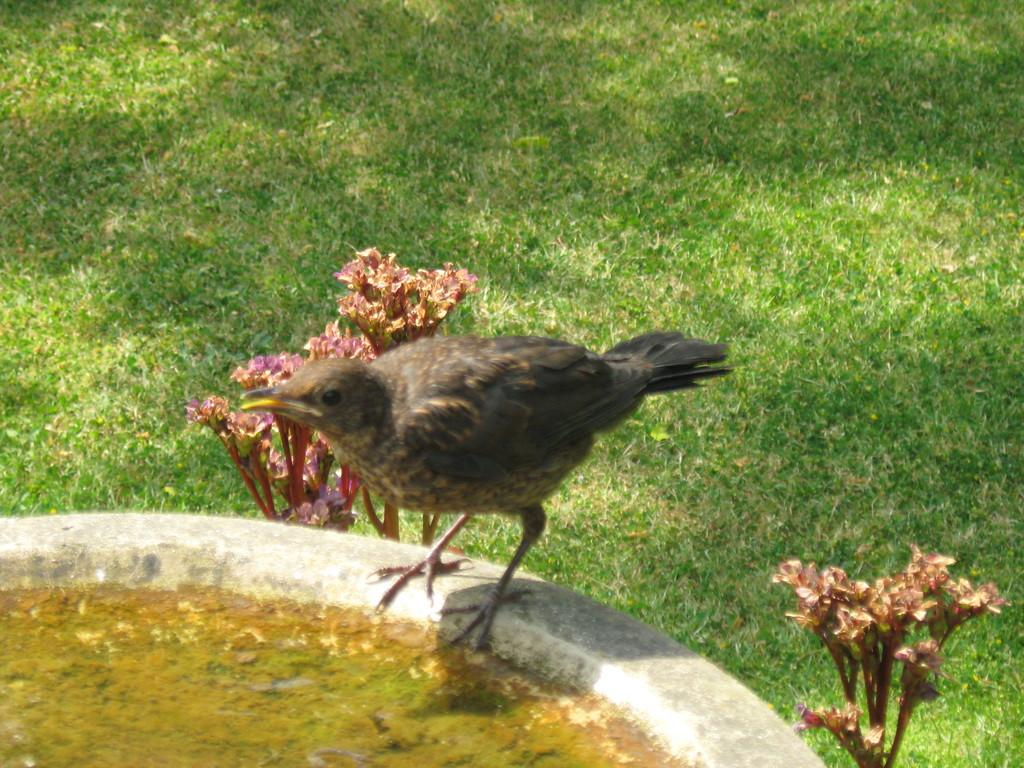What type of animal is in the image? There is a bird in the image. Where is the bird located in relation to the pond? The bird is in front of a pond. What other natural elements are present in the image? There are plants beside the bird and grass visible at the bottom of the image. What is the bird's income in the image? Birds do not have income, so this question cannot be answered. 